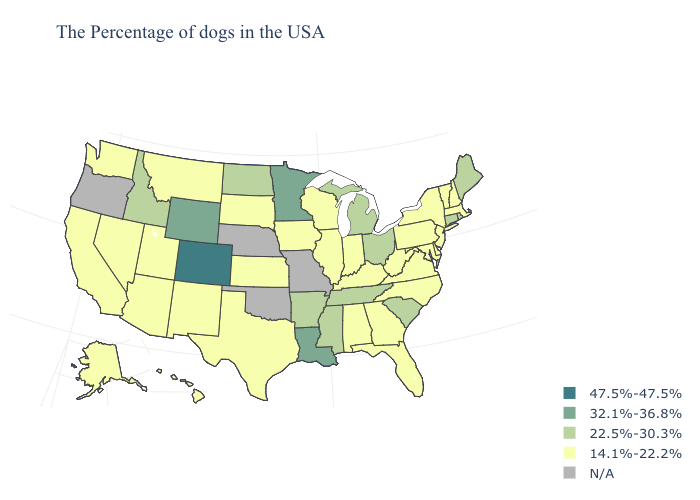What is the value of California?
Concise answer only. 14.1%-22.2%. What is the value of Louisiana?
Short answer required. 32.1%-36.8%. Among the states that border Michigan , does Ohio have the lowest value?
Short answer required. No. Which states have the lowest value in the MidWest?
Keep it brief. Indiana, Wisconsin, Illinois, Iowa, Kansas, South Dakota. Which states have the lowest value in the USA?
Answer briefly. Massachusetts, New Hampshire, Vermont, New York, New Jersey, Delaware, Maryland, Pennsylvania, Virginia, North Carolina, West Virginia, Florida, Georgia, Kentucky, Indiana, Alabama, Wisconsin, Illinois, Iowa, Kansas, Texas, South Dakota, New Mexico, Utah, Montana, Arizona, Nevada, California, Washington, Alaska, Hawaii. Name the states that have a value in the range 22.5%-30.3%?
Write a very short answer. Maine, Rhode Island, Connecticut, South Carolina, Ohio, Michigan, Tennessee, Mississippi, Arkansas, North Dakota, Idaho. Name the states that have a value in the range 32.1%-36.8%?
Be succinct. Louisiana, Minnesota, Wyoming. Which states have the lowest value in the South?
Be succinct. Delaware, Maryland, Virginia, North Carolina, West Virginia, Florida, Georgia, Kentucky, Alabama, Texas. What is the value of Massachusetts?
Short answer required. 14.1%-22.2%. What is the highest value in the South ?
Keep it brief. 32.1%-36.8%. What is the value of New Mexico?
Quick response, please. 14.1%-22.2%. Which states have the lowest value in the South?
Write a very short answer. Delaware, Maryland, Virginia, North Carolina, West Virginia, Florida, Georgia, Kentucky, Alabama, Texas. What is the lowest value in states that border New Mexico?
Concise answer only. 14.1%-22.2%. Among the states that border Iowa , which have the lowest value?
Answer briefly. Wisconsin, Illinois, South Dakota. 